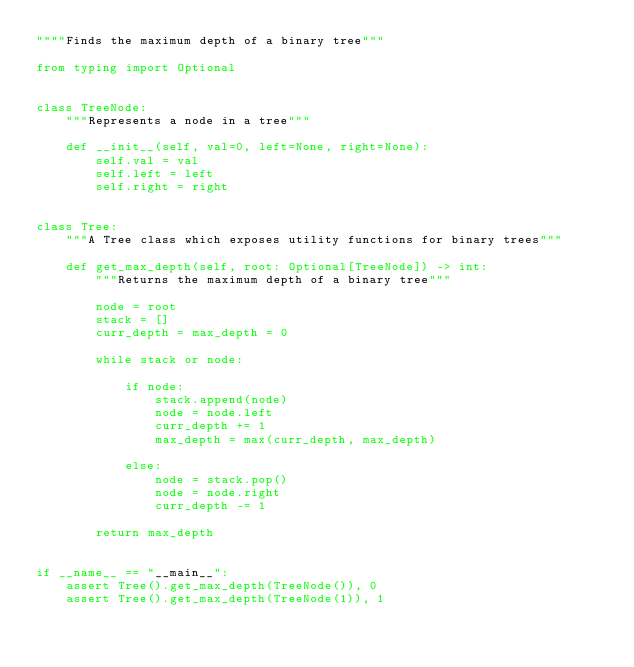<code> <loc_0><loc_0><loc_500><loc_500><_Python_>""""Finds the maximum depth of a binary tree"""

from typing import Optional


class TreeNode:
    """Represents a node in a tree"""

    def __init__(self, val=0, left=None, right=None):
        self.val = val
        self.left = left
        self.right = right


class Tree:
    """A Tree class which exposes utility functions for binary trees"""

    def get_max_depth(self, root: Optional[TreeNode]) -> int:
        """Returns the maximum depth of a binary tree"""

        node = root
        stack = []
        curr_depth = max_depth = 0

        while stack or node:

            if node:
                stack.append(node)
                node = node.left
                curr_depth += 1
                max_depth = max(curr_depth, max_depth)

            else:
                node = stack.pop()
                node = node.right
                curr_depth -= 1

        return max_depth


if __name__ == "__main__":
    assert Tree().get_max_depth(TreeNode()), 0
    assert Tree().get_max_depth(TreeNode(1)), 1
</code> 